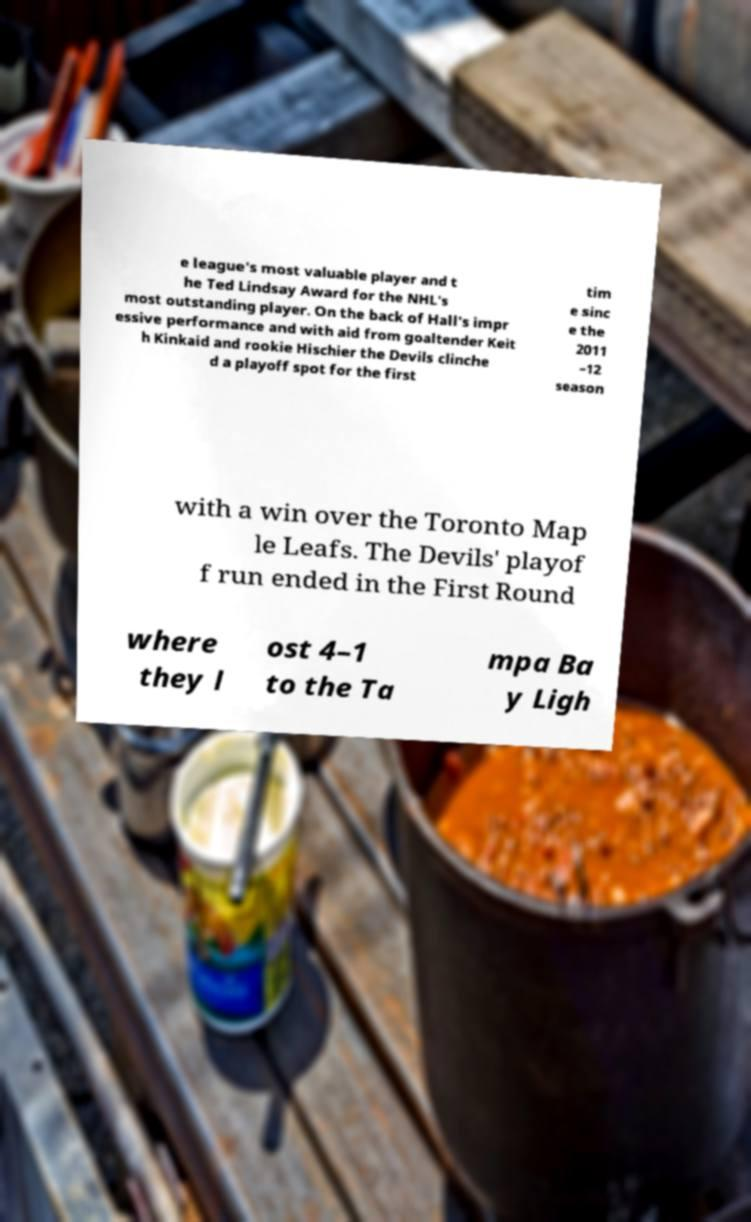I need the written content from this picture converted into text. Can you do that? e league's most valuable player and t he Ted Lindsay Award for the NHL's most outstanding player. On the back of Hall's impr essive performance and with aid from goaltender Keit h Kinkaid and rookie Hischier the Devils clinche d a playoff spot for the first tim e sinc e the 2011 –12 season with a win over the Toronto Map le Leafs. The Devils' playof f run ended in the First Round where they l ost 4–1 to the Ta mpa Ba y Ligh 